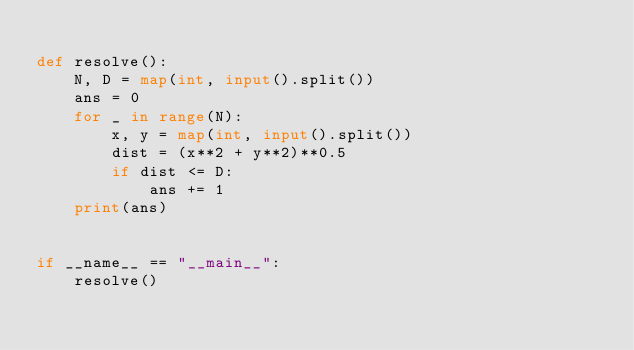Convert code to text. <code><loc_0><loc_0><loc_500><loc_500><_Python_>
def resolve():
    N, D = map(int, input().split())
    ans = 0
    for _ in range(N):
        x, y = map(int, input().split())
        dist = (x**2 + y**2)**0.5
        if dist <= D:
            ans += 1
    print(ans)


if __name__ == "__main__":
    resolve()
</code> 